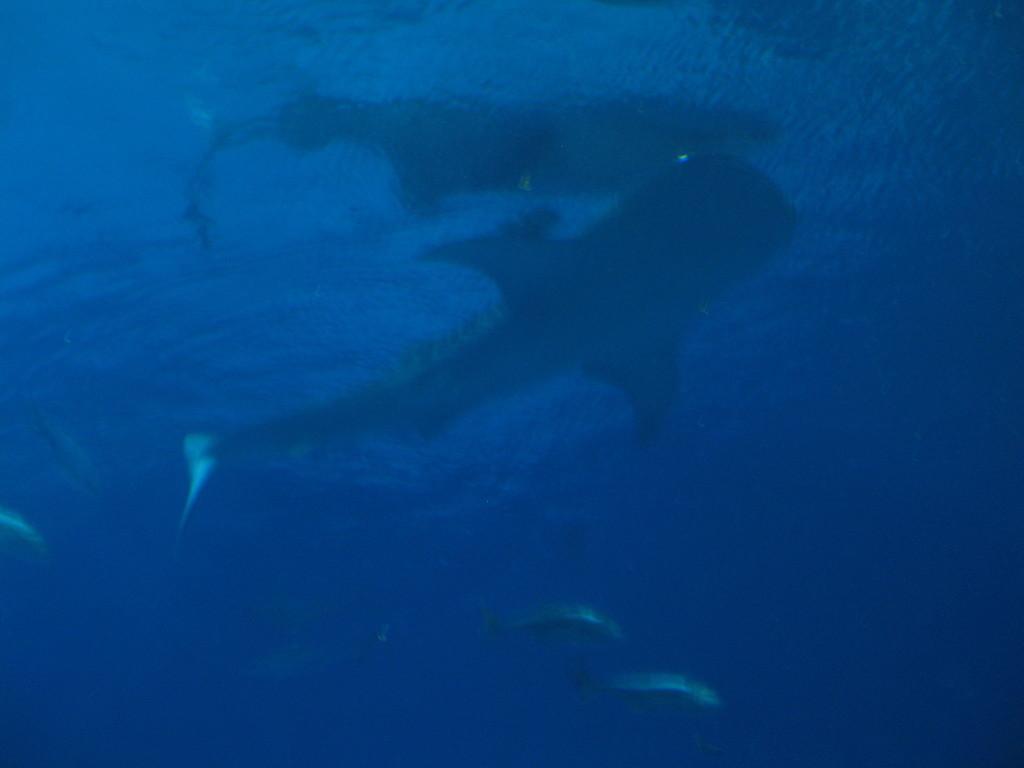How would you summarize this image in a sentence or two? In this image we can see some fishes in the water. 